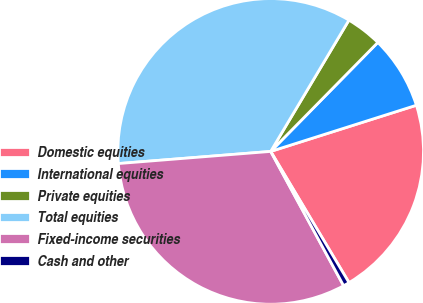Convert chart. <chart><loc_0><loc_0><loc_500><loc_500><pie_chart><fcel>Domestic equities<fcel>International equities<fcel>Private equities<fcel>Total equities<fcel>Fixed-income securities<fcel>Cash and other<nl><fcel>21.32%<fcel>7.75%<fcel>3.81%<fcel>34.82%<fcel>31.65%<fcel>0.65%<nl></chart> 